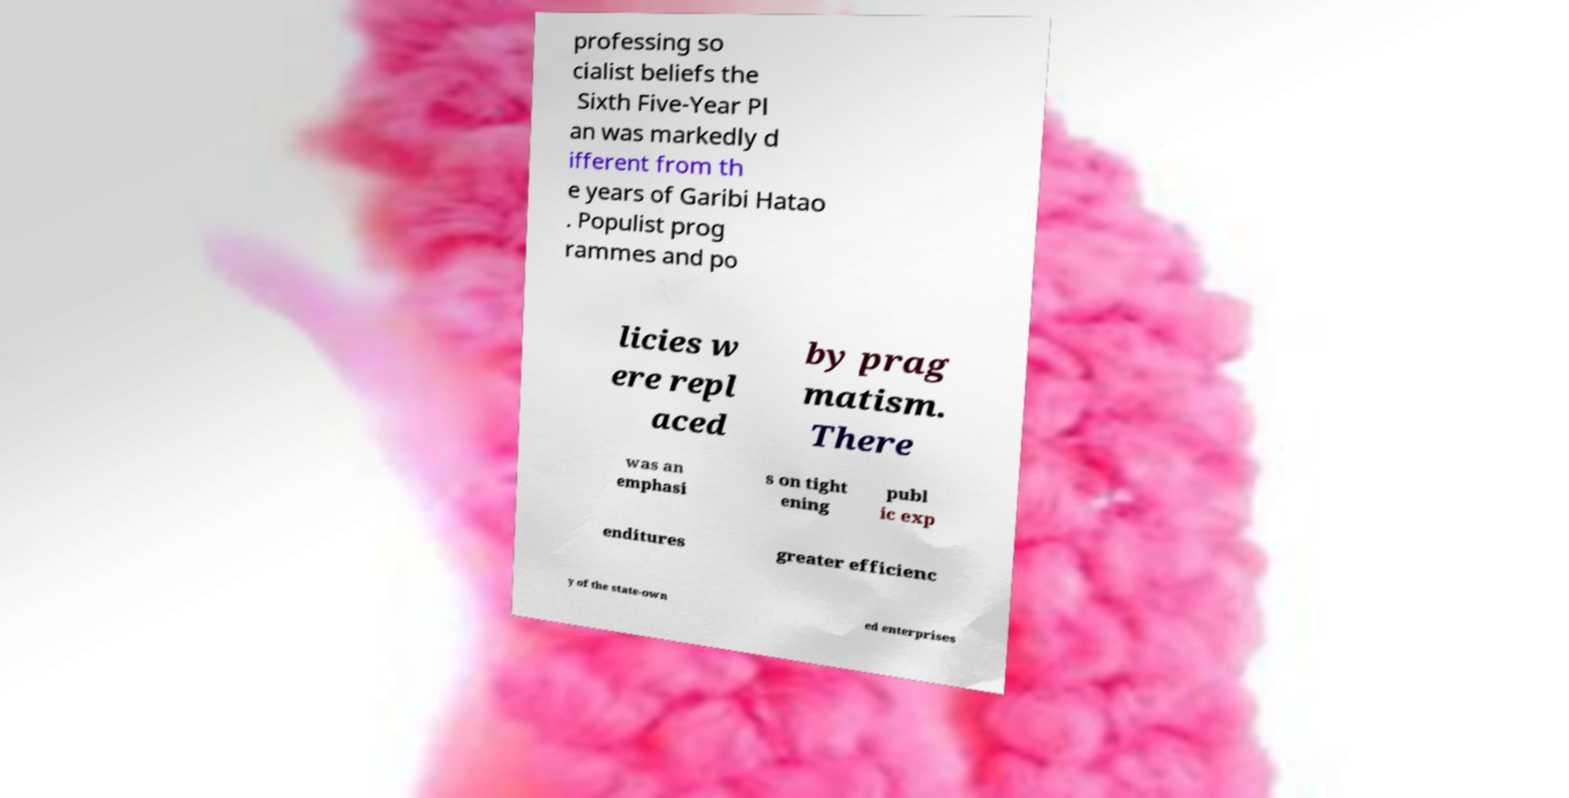Can you read and provide the text displayed in the image?This photo seems to have some interesting text. Can you extract and type it out for me? professing so cialist beliefs the Sixth Five-Year Pl an was markedly d ifferent from th e years of Garibi Hatao . Populist prog rammes and po licies w ere repl aced by prag matism. There was an emphasi s on tight ening publ ic exp enditures greater efficienc y of the state-own ed enterprises 